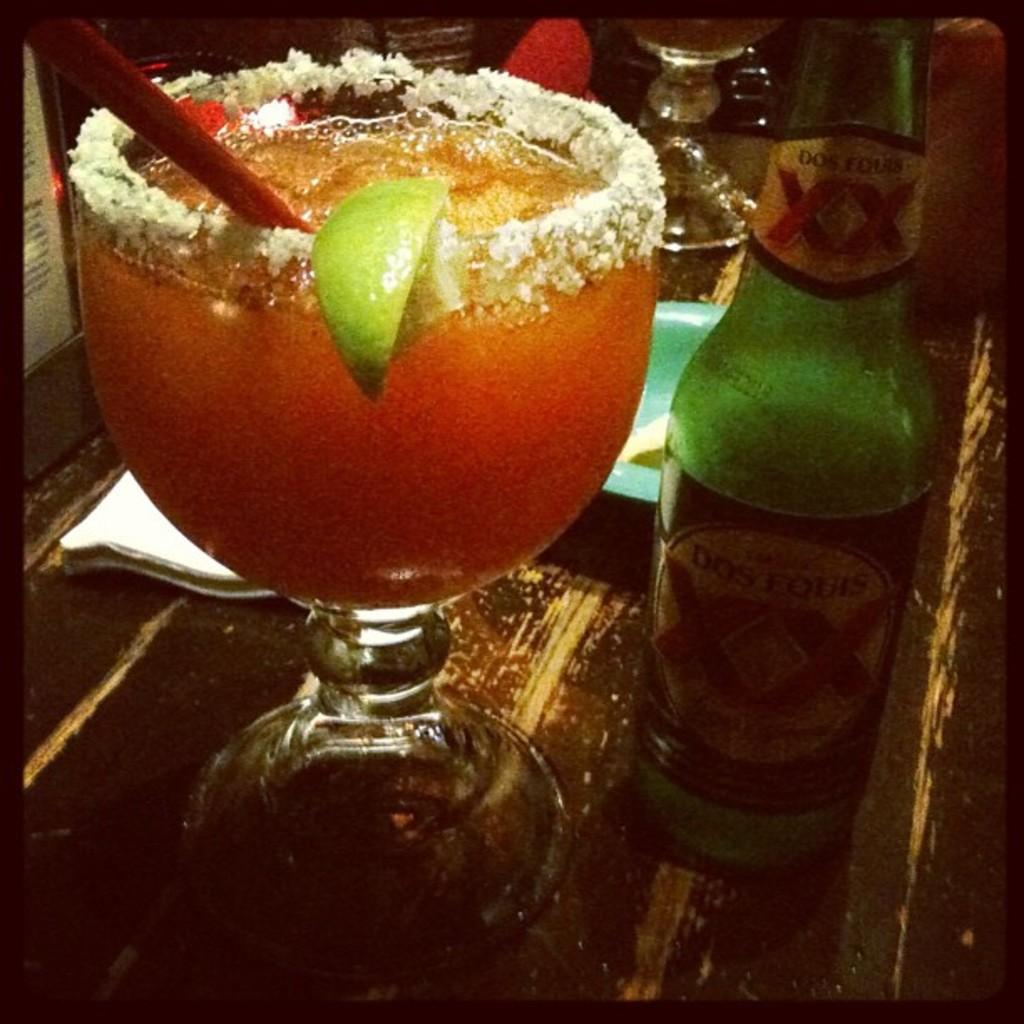<image>
Give a short and clear explanation of the subsequent image. A green bottle of Dos Equis is next to a large salt rimmed glass of margarita. 